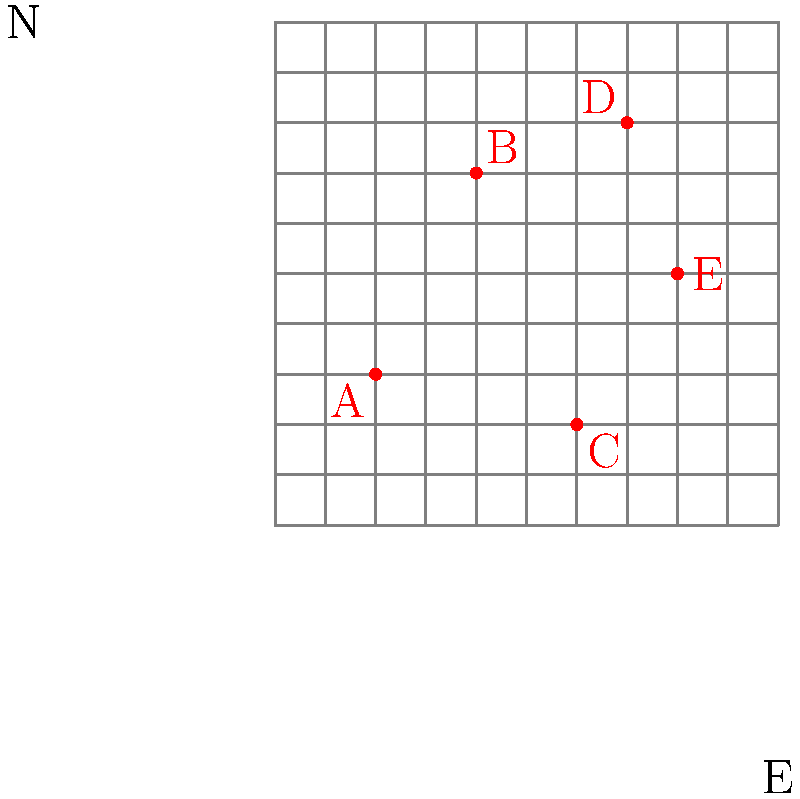As a police officer analyzing crime patterns, you've plotted recent incidents on a city grid where each unit represents one city block. The origin (0,0) is at the southwest corner, with east being the positive x-direction and north being the positive y-direction. Five crime locations (A, B, C, D, E) are marked on the grid. What is the Manhattan distance between the two crime locations that are farthest apart? To solve this problem, we need to:
1. Identify the coordinates of each crime location.
2. Calculate the Manhattan distance between each pair of locations.
3. Find the largest distance.

Step 1: Coordinates of crime locations
A: (2, 3)
B: (4, 7)
C: (6, 2)
D: (7, 8)
E: (8, 5)

Step 2: Calculate Manhattan distances
The Manhattan distance between two points $(x_1, y_1)$ and $(x_2, y_2)$ is given by:
$$|x_2 - x_1| + |y_2 - y_1|$$

We need to calculate the distance between each pair:
AB: $|4-2| + |7-3| = 2 + 4 = 6$
AC: $|6-2| + |2-3| = 4 + 1 = 5$
AD: $|7-2| + |8-3| = 5 + 5 = 10$
AE: $|8-2| + |5-3| = 6 + 2 = 8$
BC: $|6-4| + |2-7| = 2 + 5 = 7$
BD: $|7-4| + |8-7| = 3 + 1 = 4$
BE: $|8-4| + |5-7| = 4 + 2 = 6$
CD: $|7-6| + |8-2| = 1 + 6 = 7$
CE: $|8-6| + |5-2| = 2 + 3 = 5$
DE: $|8-7| + |5-8| = 1 + 3 = 4$

Step 3: Find the largest distance
The largest Manhattan distance is 10, between points A and D.
Answer: 10 blocks 